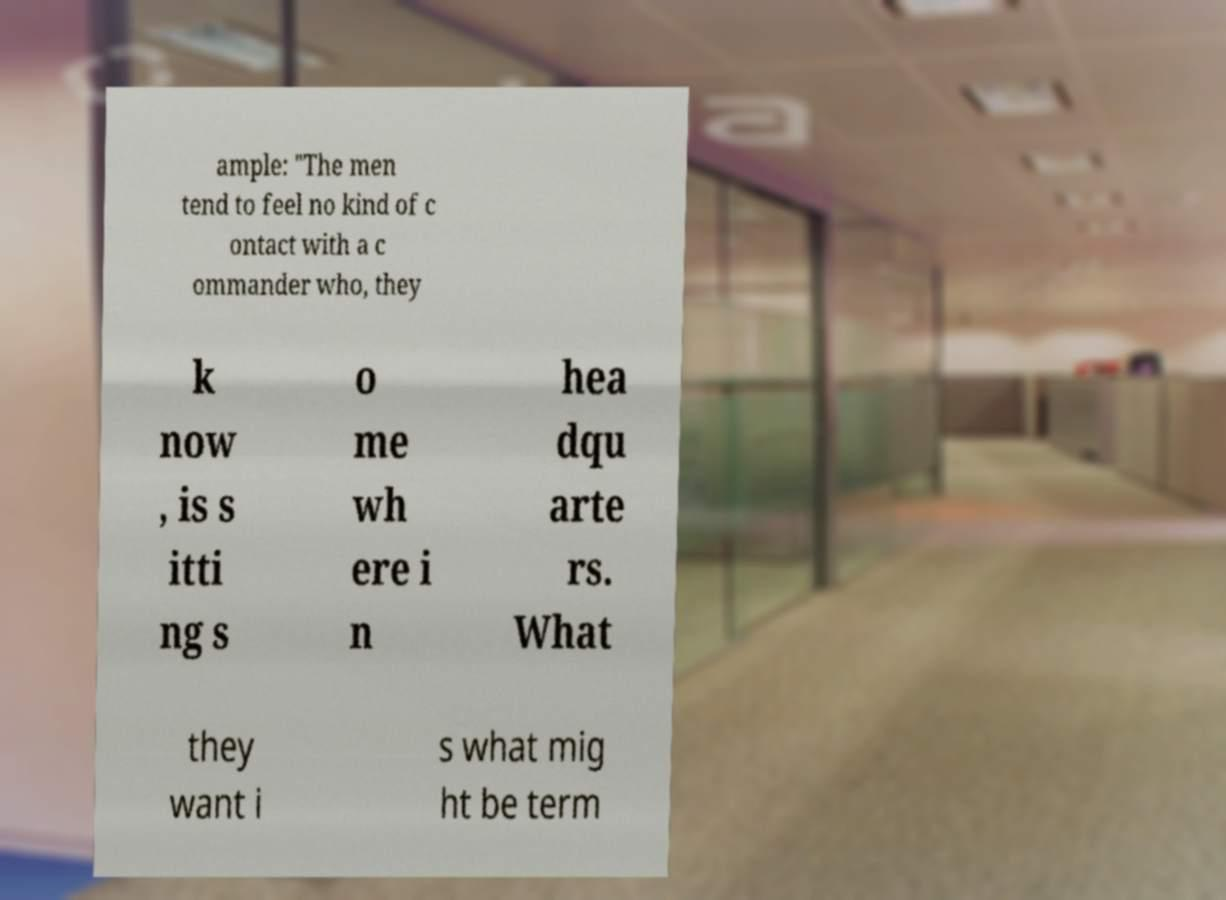What messages or text are displayed in this image? I need them in a readable, typed format. ample: "The men tend to feel no kind of c ontact with a c ommander who, they k now , is s itti ng s o me wh ere i n hea dqu arte rs. What they want i s what mig ht be term 